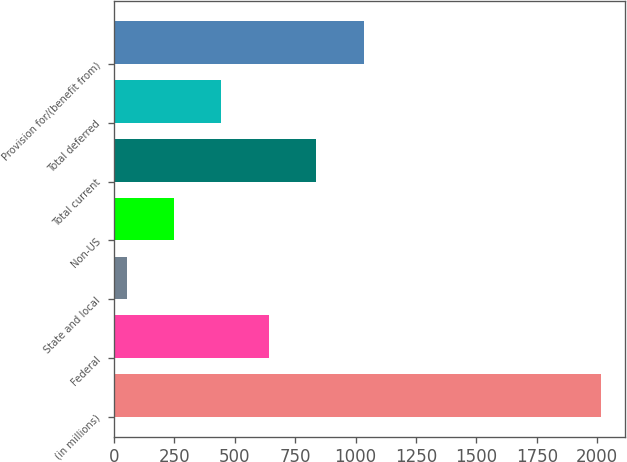Convert chart to OTSL. <chart><loc_0><loc_0><loc_500><loc_500><bar_chart><fcel>(in millions)<fcel>Federal<fcel>State and local<fcel>Non-US<fcel>Total current<fcel>Total deferred<fcel>Provision for/(benefit from)<nl><fcel>2016<fcel>641.2<fcel>52<fcel>248.4<fcel>837.6<fcel>444.8<fcel>1034<nl></chart> 